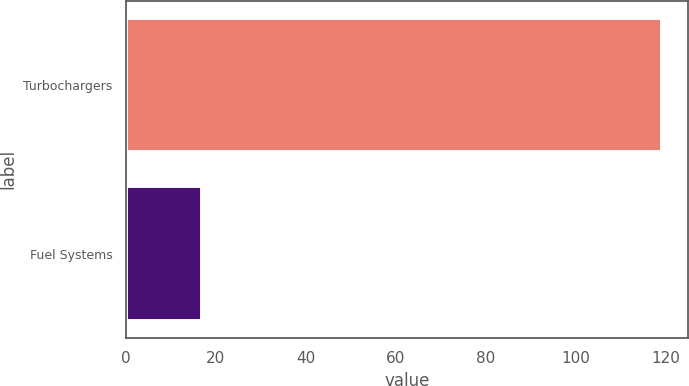Convert chart. <chart><loc_0><loc_0><loc_500><loc_500><bar_chart><fcel>Turbochargers<fcel>Fuel Systems<nl><fcel>119<fcel>17<nl></chart> 